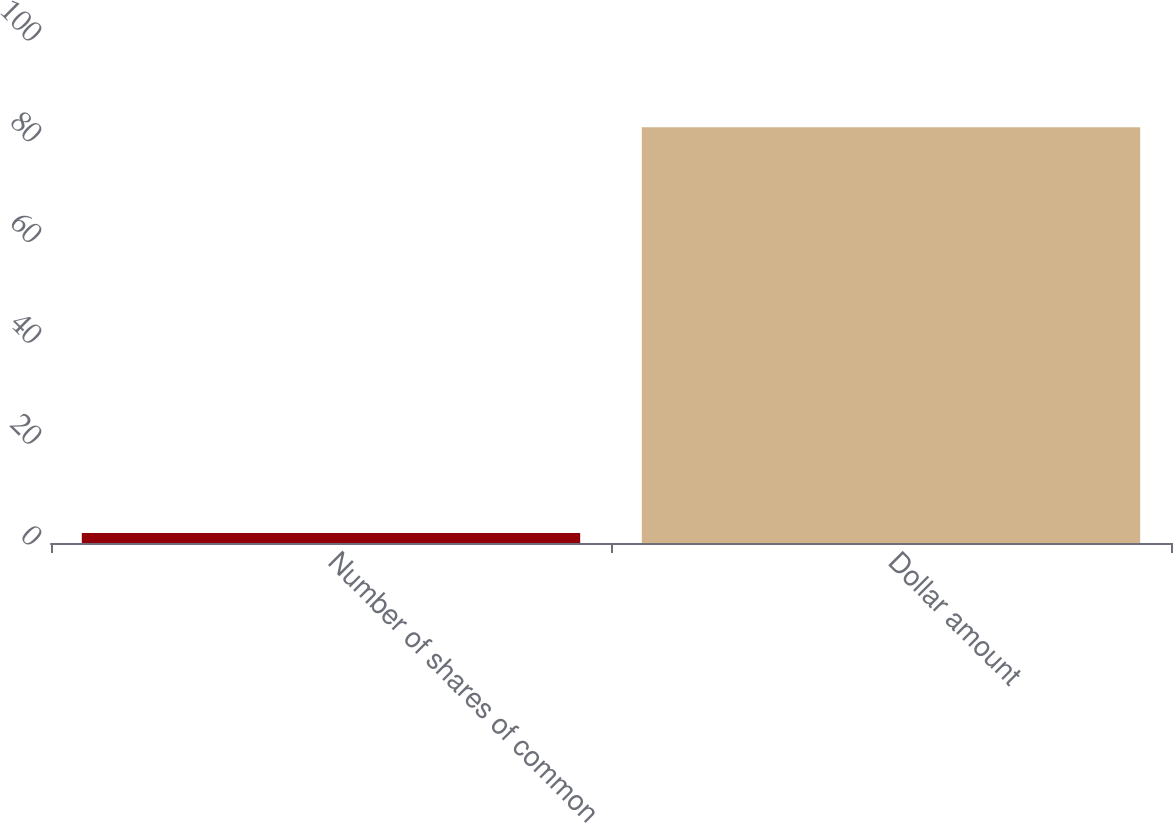Convert chart. <chart><loc_0><loc_0><loc_500><loc_500><bar_chart><fcel>Number of shares of common<fcel>Dollar amount<nl><fcel>2<fcel>82.5<nl></chart> 